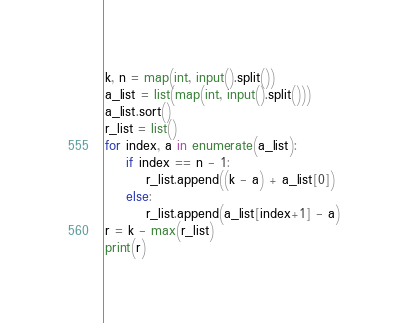Convert code to text. <code><loc_0><loc_0><loc_500><loc_500><_Python_>k, n = map(int, input().split())
a_list = list(map(int, input().split()))
a_list.sort()
r_list = list()
for index, a in enumerate(a_list):
	if index == n - 1:
		r_list.append((k - a) + a_list[0])
	else:
		r_list.append(a_list[index+1] - a)
r = k - max(r_list)
print(r)
</code> 